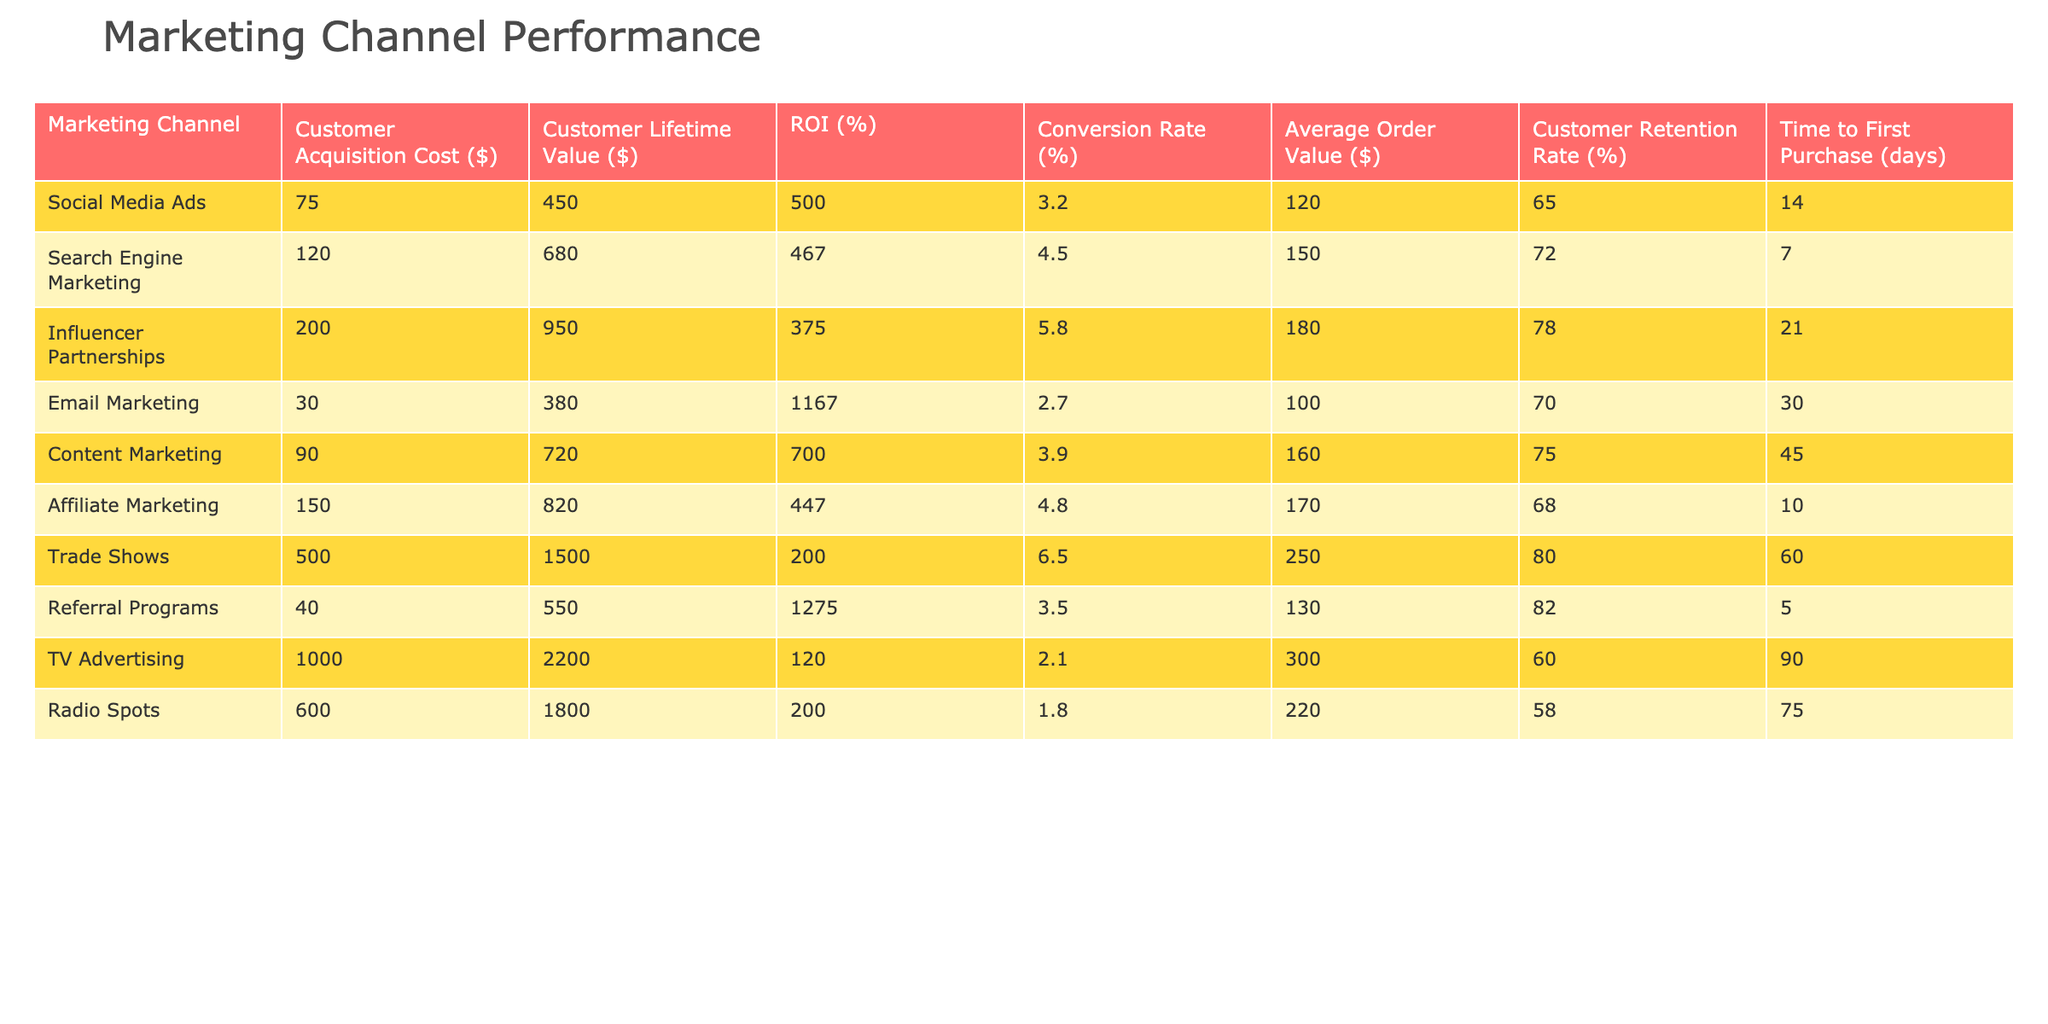What is the Customer Acquisition Cost for Email Marketing? Referring to the table, the Customer Acquisition Cost for Email Marketing is directly listed as $30.
Answer: 30 Which marketing channel has the highest Customer Lifetime Value? From the table, the channel with the highest Customer Lifetime Value is TV Advertising, which is $2,200.
Answer: 2200 What is the ROI for Referral Programs? The table indicates that the ROI for Referral Programs is 1275%.
Answer: 1275 Which channels have a Conversion Rate greater than 4%? By checking the Conversion Rates, the channels with more than 4% are Search Engine Marketing (4.5%), Influencer Partnerships (5.8%), Affiliate Marketing (4.8%), and Trade Shows (6.5%).
Answer: Search Engine Marketing, Influencer Partnerships, Affiliate Marketing, Trade Shows What is the difference between the Average Order Value of Trade Shows and Social Media Ads? The Average Order Value for Trade Shows is $250 and for Social Media Ads is $120. The difference is $250 - $120 = $130.
Answer: 130 Which marketing channel requires the most time to the first purchase? Scanning the table, the time to the first purchase for TV Advertising is shown as 90 days, which is the highest among all channels.
Answer: 90 What is the average Customer Retention Rate across all channels? The Customer Retention Rates for each channel are 65, 72, 78, 70, 75, 68, 80, 82, 60, and 58. Summing these gives  65 + 72 + 78 + 70 + 75 + 68 + 80 + 82 + 60 + 58 =  738, and dividing by 10 gives an average of 73.8%.
Answer: 73.8 Is the Customer Acquisition Cost for Influencer Partnerships less than the Average Order Value? The Customer Acquisition Cost for Influencer Partnerships is $200 and the Average Order Value is $180. Thus, $200 is greater than $180, so the answer is no.
Answer: No Which channel has the best ROI considering the ratio of Customer Lifetime Value to Customer Acquisition Cost? The ROI can be computed by taking the ratio of Customer Lifetime Value and Customer Acquisition Cost for each marketing channel. Calculating these ratios, Email Marketing has the best ratio at 1275% when dividing $380 by $30.
Answer: Email Marketing What marketing channel has the highest conversion rate and how much is it? From the table, Influencer Partnerships have the highest Conversion Rate at 5.8%.
Answer: Influencer Partnerships, 5.8 